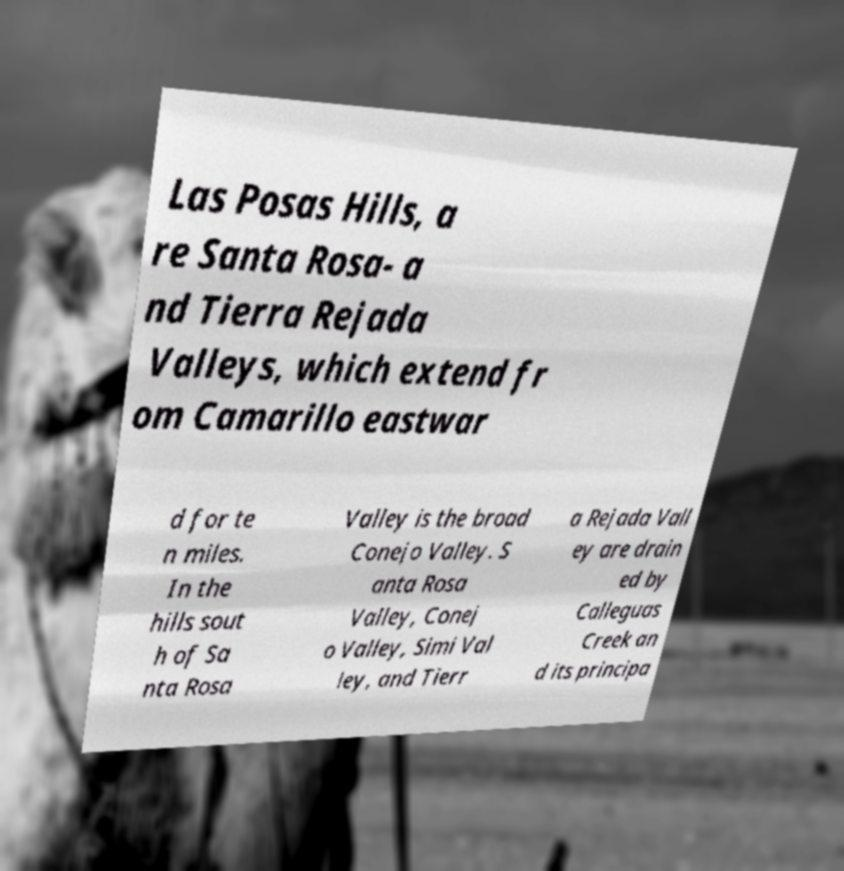Can you accurately transcribe the text from the provided image for me? Las Posas Hills, a re Santa Rosa- a nd Tierra Rejada Valleys, which extend fr om Camarillo eastwar d for te n miles. In the hills sout h of Sa nta Rosa Valley is the broad Conejo Valley. S anta Rosa Valley, Conej o Valley, Simi Val ley, and Tierr a Rejada Vall ey are drain ed by Calleguas Creek an d its principa 